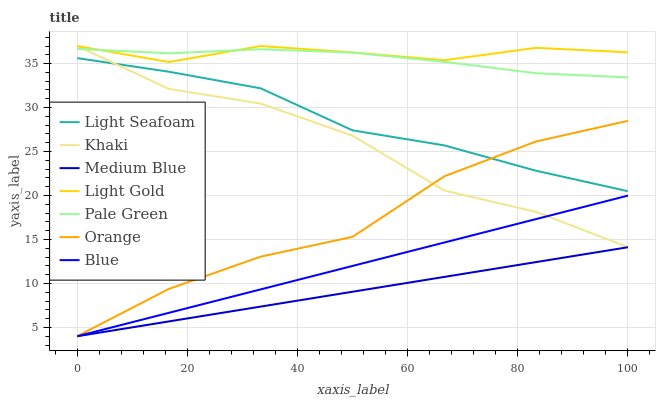Does Medium Blue have the minimum area under the curve?
Answer yes or no. Yes. Does Light Gold have the maximum area under the curve?
Answer yes or no. Yes. Does Khaki have the minimum area under the curve?
Answer yes or no. No. Does Khaki have the maximum area under the curve?
Answer yes or no. No. Is Blue the smoothest?
Answer yes or no. Yes. Is Khaki the roughest?
Answer yes or no. Yes. Is Medium Blue the smoothest?
Answer yes or no. No. Is Medium Blue the roughest?
Answer yes or no. No. Does Blue have the lowest value?
Answer yes or no. Yes. Does Khaki have the lowest value?
Answer yes or no. No. Does Light Gold have the highest value?
Answer yes or no. Yes. Does Medium Blue have the highest value?
Answer yes or no. No. Is Blue less than Light Seafoam?
Answer yes or no. Yes. Is Light Gold greater than Blue?
Answer yes or no. Yes. Does Light Gold intersect Khaki?
Answer yes or no. Yes. Is Light Gold less than Khaki?
Answer yes or no. No. Is Light Gold greater than Khaki?
Answer yes or no. No. Does Blue intersect Light Seafoam?
Answer yes or no. No. 